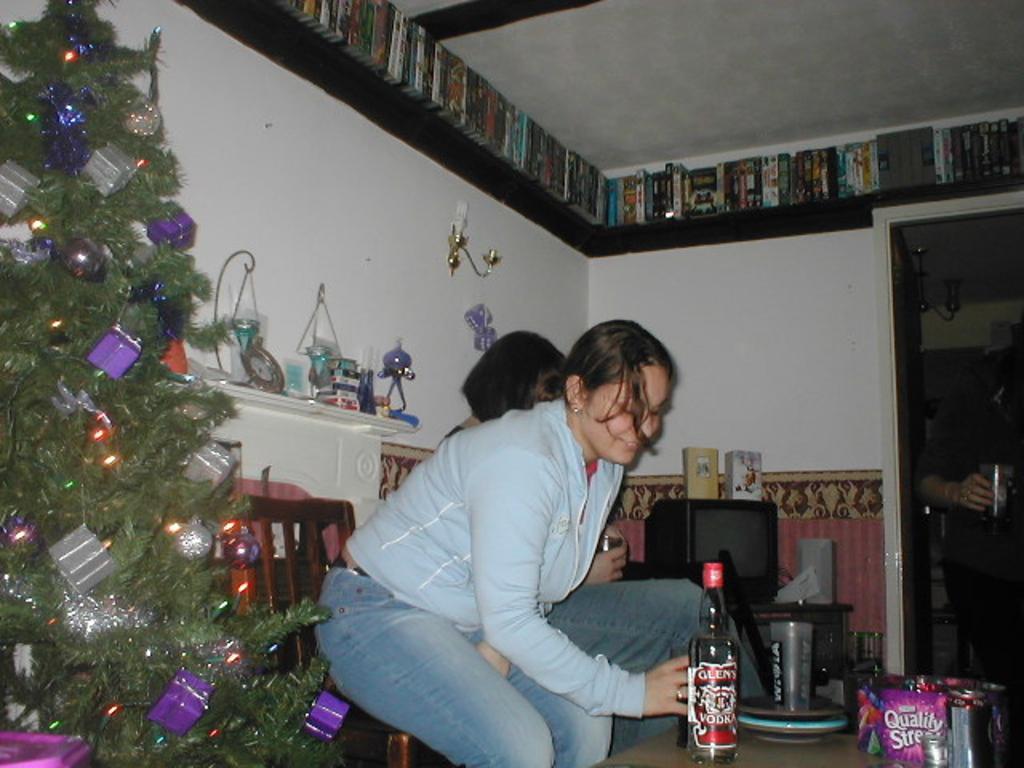How would you summarize this image in a sentence or two? In this image there are two persons sitting on the chairs at bottom of this image and there is one table at bottom right corner of this image and there are some bottles and other objects are kept on it. There is one person standing at right side of this image is holding a glass, and there is a wall in the background. There is a Christmas tree at left side of this image. There is a television at right side of this image and there are some objects kept at middle of this image. and there are some books kept at top of this image. 